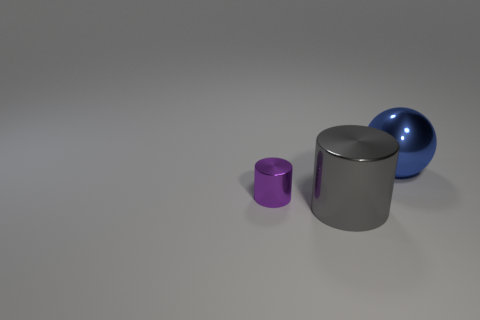Add 3 cyan shiny spheres. How many objects exist? 6 Subtract all spheres. How many objects are left? 2 Add 2 big things. How many big things exist? 4 Subtract 0 cyan cubes. How many objects are left? 3 Subtract all red cubes. Subtract all large metallic balls. How many objects are left? 2 Add 1 big gray objects. How many big gray objects are left? 2 